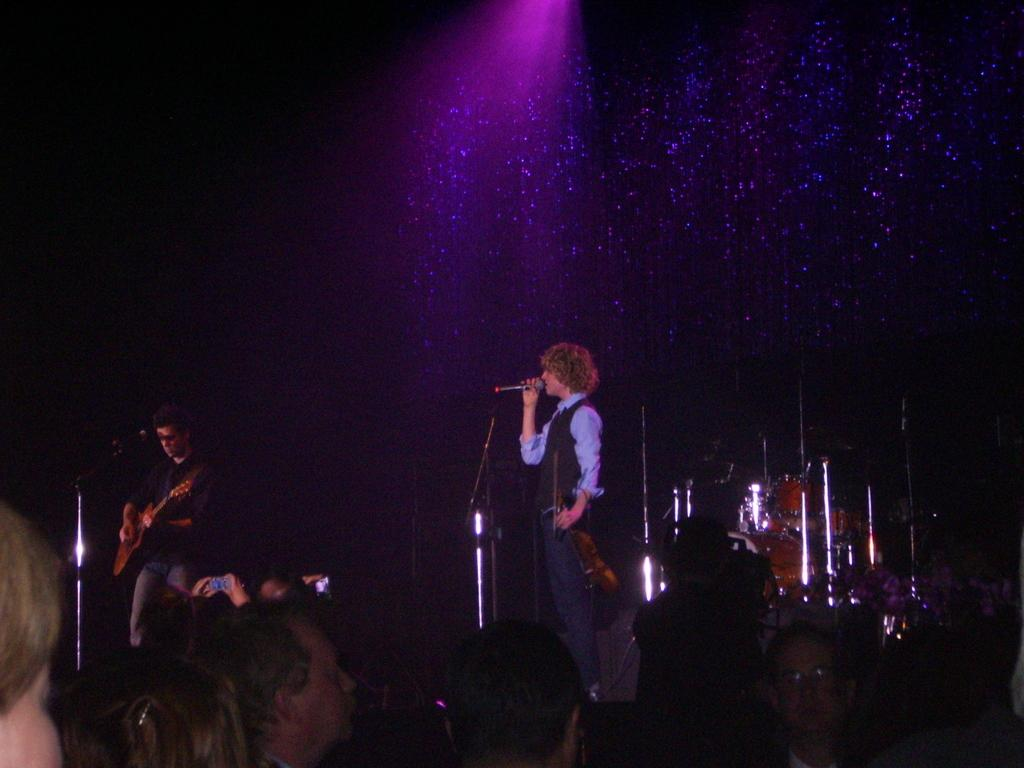What is the man on the stage doing? The man on the stage is singing into a microphone. Who is accompanying the singer on stage? There is another man standing with a guitar. Are there any other people present in the image? Yes, there are people standing in the image. What type of drum can be seen in the aftermath of the performance? There is no drum present in the image, and the term "aftermath" is not relevant to the scene depicted. 